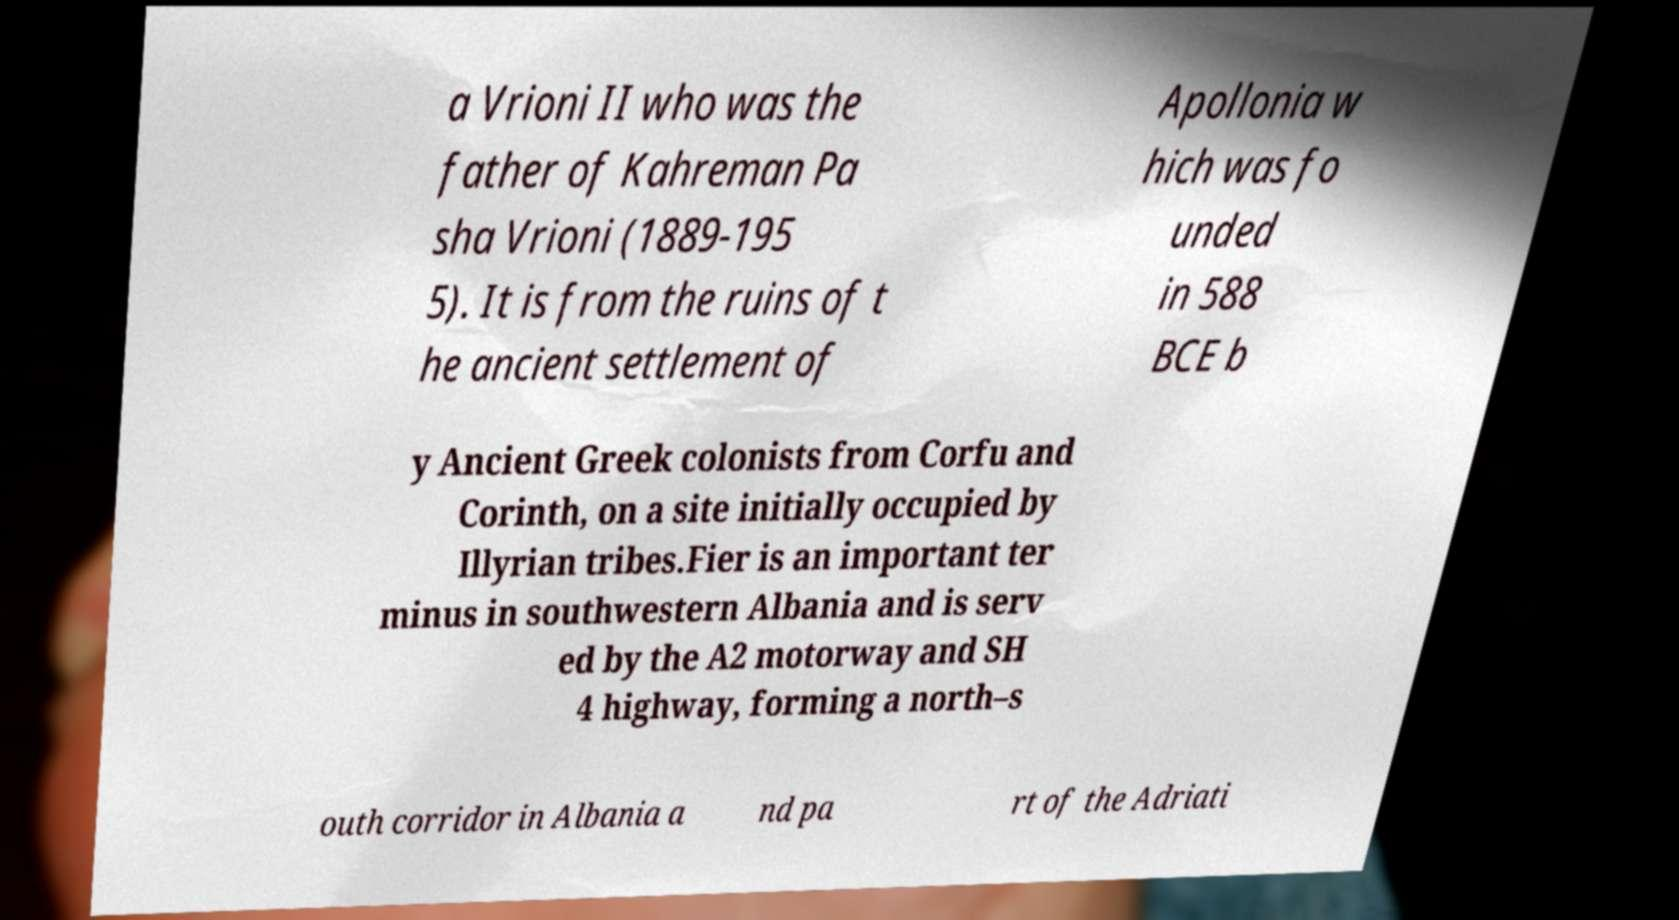What messages or text are displayed in this image? I need them in a readable, typed format. a Vrioni II who was the father of Kahreman Pa sha Vrioni (1889-195 5). It is from the ruins of t he ancient settlement of Apollonia w hich was fo unded in 588 BCE b y Ancient Greek colonists from Corfu and Corinth, on a site initially occupied by Illyrian tribes.Fier is an important ter minus in southwestern Albania and is serv ed by the A2 motorway and SH 4 highway, forming a north–s outh corridor in Albania a nd pa rt of the Adriati 